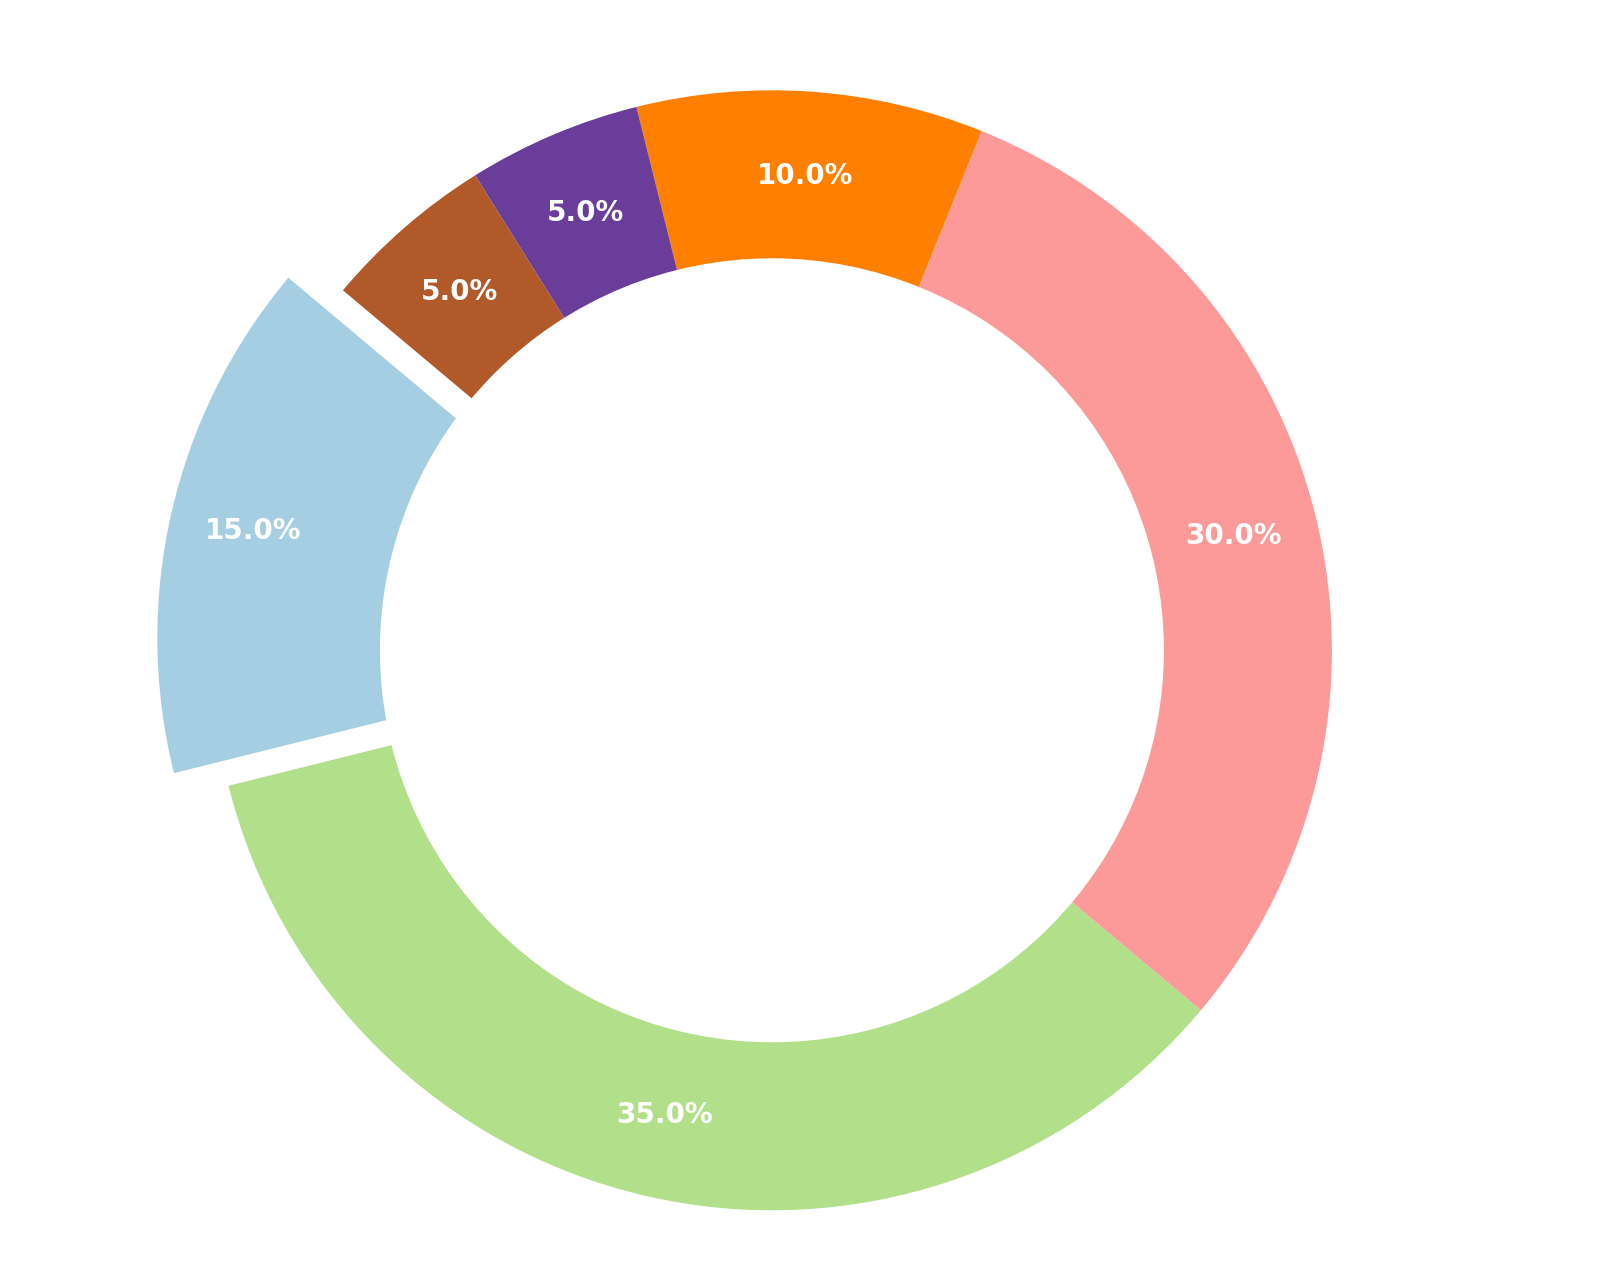What percentage of the market share does Wind energy have? Look at the segment labeled "Wind" on the ring chart. The percentage value is written directly on the segment.
Answer: 35% Is Solar energy's market share larger than Biomass energy's market share? Compare the segments labeled "Solar" and "Biomass." Solar has a market share of 15% and Biomass has a market share of 10%.
Answer: Yes What is the combined market share of Hydropower and Geothermal energy? Add the percentages of the segments labeled "Hydropower" and "Geothermal": 30% (Hydropower) + 5% (Geothermal) = 35%
Answer: 35% How much larger is Wind energy's market share compared to Solar energy's market share? Subtract the percentage of the Solar segment from the Wind segment: 35% (Wind) - 15% (Solar) = 20%
Answer: 20% Which energy source has the smallest market share and what is its value? Identify the segment with the smallest percentage. The segment labeled "Geothermal" and "Others" both carry a 5% share.
Answer: Geothermal and Others, 5% How much bigger is the combined share of Solar and Biomass compared to Geothermal? Add the percentages of Solar and Biomass (15% + 10% = 25%) and then subtract the percentage of Geothermal (5%): 25% - 5% = 20%
Answer: 20% Among the listed energy sources, which two have an equal market share? Identify segments with equal percentages. Both Geothermal and Others have a market share of 5%.
Answer: Geothermal and Others What energy source has a market share closest to 1/3 of the total market? Calculate 1/3 of 100%, which is approximately 33.3%. The segment closest to this value is Wind with a 35% share.
Answer: Wind Which segment is emphasized in the chart and why? Look for the segment that is separated or "exploded" from the rest. The Wind segment is exploded, emphasizing its largest share.
Answer: Wind 